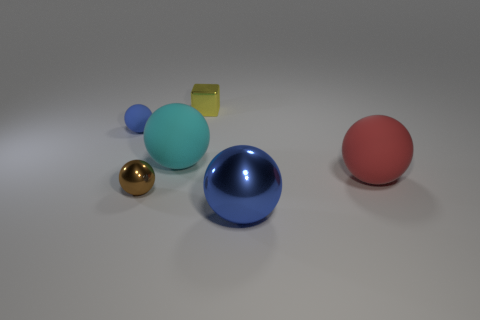Subtract all cyan balls. How many balls are left? 4 Subtract all red spheres. Subtract all red cylinders. How many spheres are left? 4 Add 4 blue objects. How many objects exist? 10 Subtract all spheres. How many objects are left? 1 Subtract all big cyan spheres. Subtract all cyan things. How many objects are left? 4 Add 6 big rubber spheres. How many big rubber spheres are left? 8 Add 1 blue matte objects. How many blue matte objects exist? 2 Subtract 0 yellow balls. How many objects are left? 6 